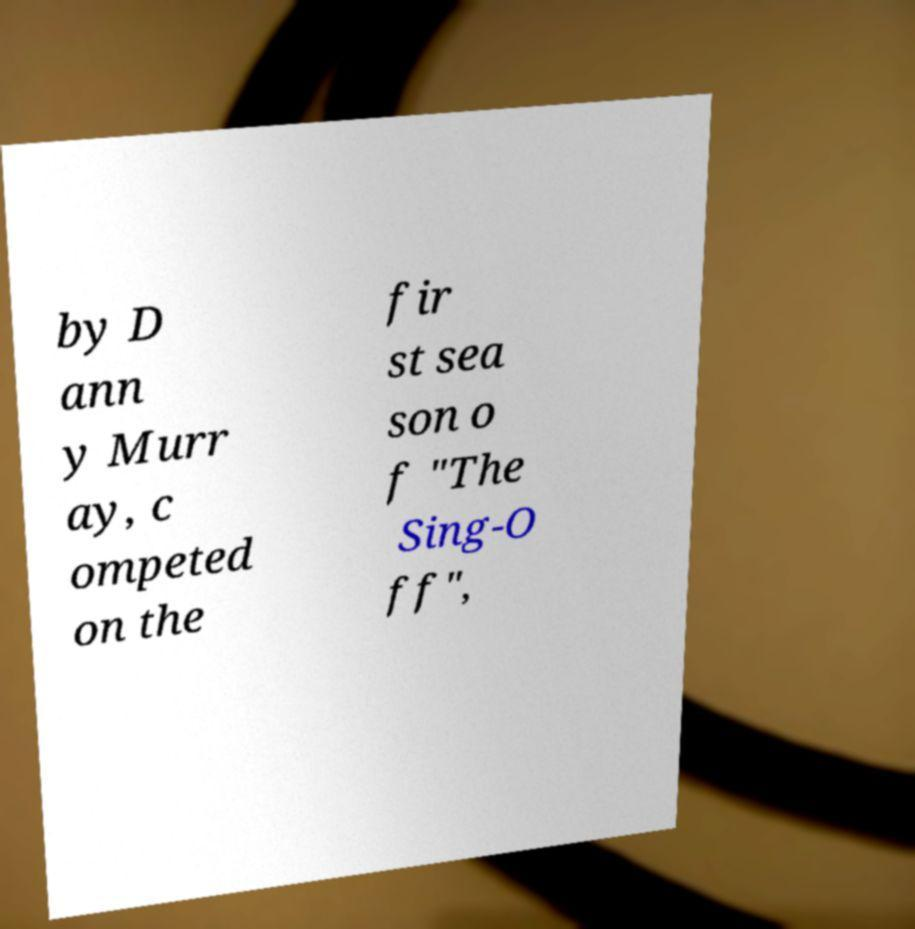What messages or text are displayed in this image? I need them in a readable, typed format. by D ann y Murr ay, c ompeted on the fir st sea son o f "The Sing-O ff", 